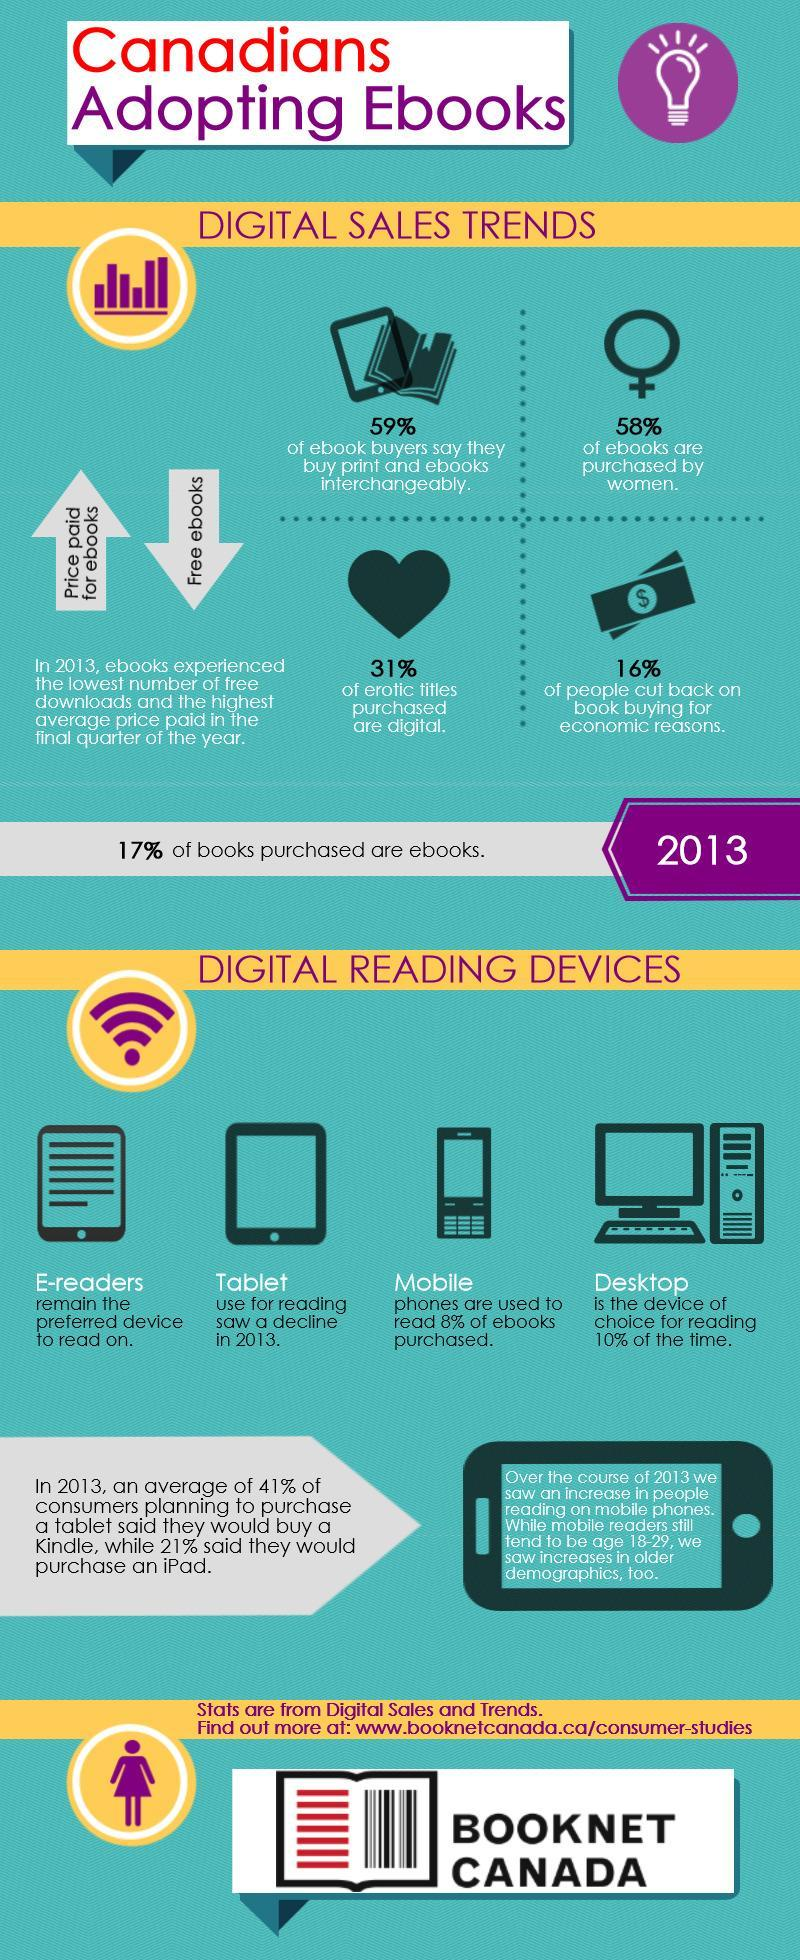What is the inverse percentage of eBooks bought by females?
Answer the question with a short phrase. 42 Which device is used mostly for reading eBooks? Desktop What is the inverse percentage of eBooks bought in the year 2013? 83 